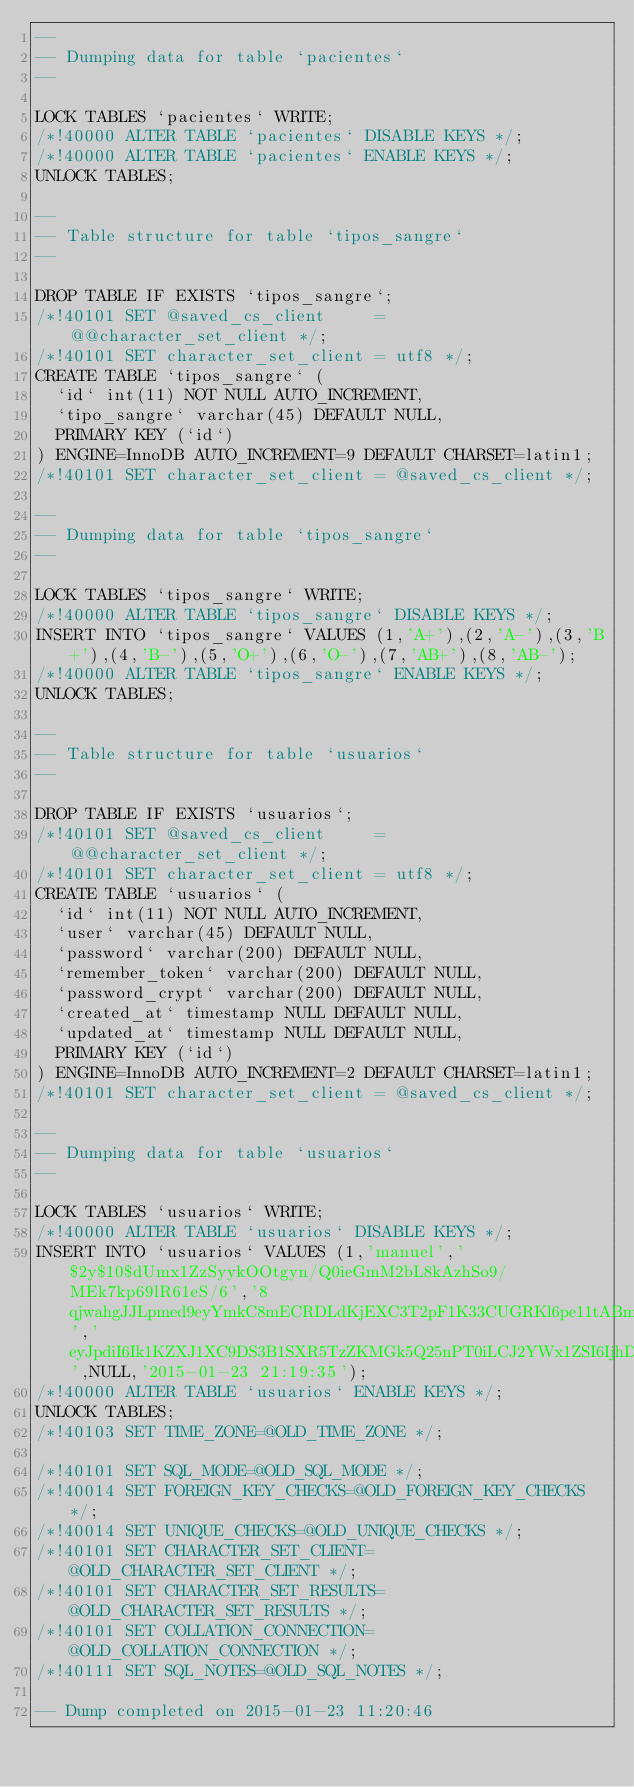<code> <loc_0><loc_0><loc_500><loc_500><_SQL_>--
-- Dumping data for table `pacientes`
--

LOCK TABLES `pacientes` WRITE;
/*!40000 ALTER TABLE `pacientes` DISABLE KEYS */;
/*!40000 ALTER TABLE `pacientes` ENABLE KEYS */;
UNLOCK TABLES;

--
-- Table structure for table `tipos_sangre`
--

DROP TABLE IF EXISTS `tipos_sangre`;
/*!40101 SET @saved_cs_client     = @@character_set_client */;
/*!40101 SET character_set_client = utf8 */;
CREATE TABLE `tipos_sangre` (
  `id` int(11) NOT NULL AUTO_INCREMENT,
  `tipo_sangre` varchar(45) DEFAULT NULL,
  PRIMARY KEY (`id`)
) ENGINE=InnoDB AUTO_INCREMENT=9 DEFAULT CHARSET=latin1;
/*!40101 SET character_set_client = @saved_cs_client */;

--
-- Dumping data for table `tipos_sangre`
--

LOCK TABLES `tipos_sangre` WRITE;
/*!40000 ALTER TABLE `tipos_sangre` DISABLE KEYS */;
INSERT INTO `tipos_sangre` VALUES (1,'A+'),(2,'A-'),(3,'B+'),(4,'B-'),(5,'O+'),(6,'O-'),(7,'AB+'),(8,'AB-');
/*!40000 ALTER TABLE `tipos_sangre` ENABLE KEYS */;
UNLOCK TABLES;

--
-- Table structure for table `usuarios`
--

DROP TABLE IF EXISTS `usuarios`;
/*!40101 SET @saved_cs_client     = @@character_set_client */;
/*!40101 SET character_set_client = utf8 */;
CREATE TABLE `usuarios` (
  `id` int(11) NOT NULL AUTO_INCREMENT,
  `user` varchar(45) DEFAULT NULL,
  `password` varchar(200) DEFAULT NULL,
  `remember_token` varchar(200) DEFAULT NULL,
  `password_crypt` varchar(200) DEFAULT NULL,
  `created_at` timestamp NULL DEFAULT NULL,
  `updated_at` timestamp NULL DEFAULT NULL,
  PRIMARY KEY (`id`)
) ENGINE=InnoDB AUTO_INCREMENT=2 DEFAULT CHARSET=latin1;
/*!40101 SET character_set_client = @saved_cs_client */;

--
-- Dumping data for table `usuarios`
--

LOCK TABLES `usuarios` WRITE;
/*!40000 ALTER TABLE `usuarios` DISABLE KEYS */;
INSERT INTO `usuarios` VALUES (1,'manuel','$2y$10$dUmx1ZzSyykOOtgyn/Q0ieGmM2bL8kAzhSo9/MEk7kp69lR61eS/6','8qjwahgJJLpmed9eyYmkC8mECRDLdKjEXC3T2pF1K33CUGRKl6pe11tABmdP','eyJpdiI6Ik1KZXJ1XC9DS3B1SXR5TzZKMGk5Q25nPT0iLCJ2YWx1ZSI6IjhDRWlYS241TEkzSWtmQ0dEbnZqV2c9PSIsIm1hYyI6ImIyYWIyMmFjZmNmNWQ3NjM2ZmM4NDU0NWQwZjkxMmQ1ZDlkZTBmZmM3MzM0ZjBlMzM2NjhjYmFlNzA5OTBlYjYifQ',NULL,'2015-01-23 21:19:35');
/*!40000 ALTER TABLE `usuarios` ENABLE KEYS */;
UNLOCK TABLES;
/*!40103 SET TIME_ZONE=@OLD_TIME_ZONE */;

/*!40101 SET SQL_MODE=@OLD_SQL_MODE */;
/*!40014 SET FOREIGN_KEY_CHECKS=@OLD_FOREIGN_KEY_CHECKS */;
/*!40014 SET UNIQUE_CHECKS=@OLD_UNIQUE_CHECKS */;
/*!40101 SET CHARACTER_SET_CLIENT=@OLD_CHARACTER_SET_CLIENT */;
/*!40101 SET CHARACTER_SET_RESULTS=@OLD_CHARACTER_SET_RESULTS */;
/*!40101 SET COLLATION_CONNECTION=@OLD_COLLATION_CONNECTION */;
/*!40111 SET SQL_NOTES=@OLD_SQL_NOTES */;

-- Dump completed on 2015-01-23 11:20:46
</code> 